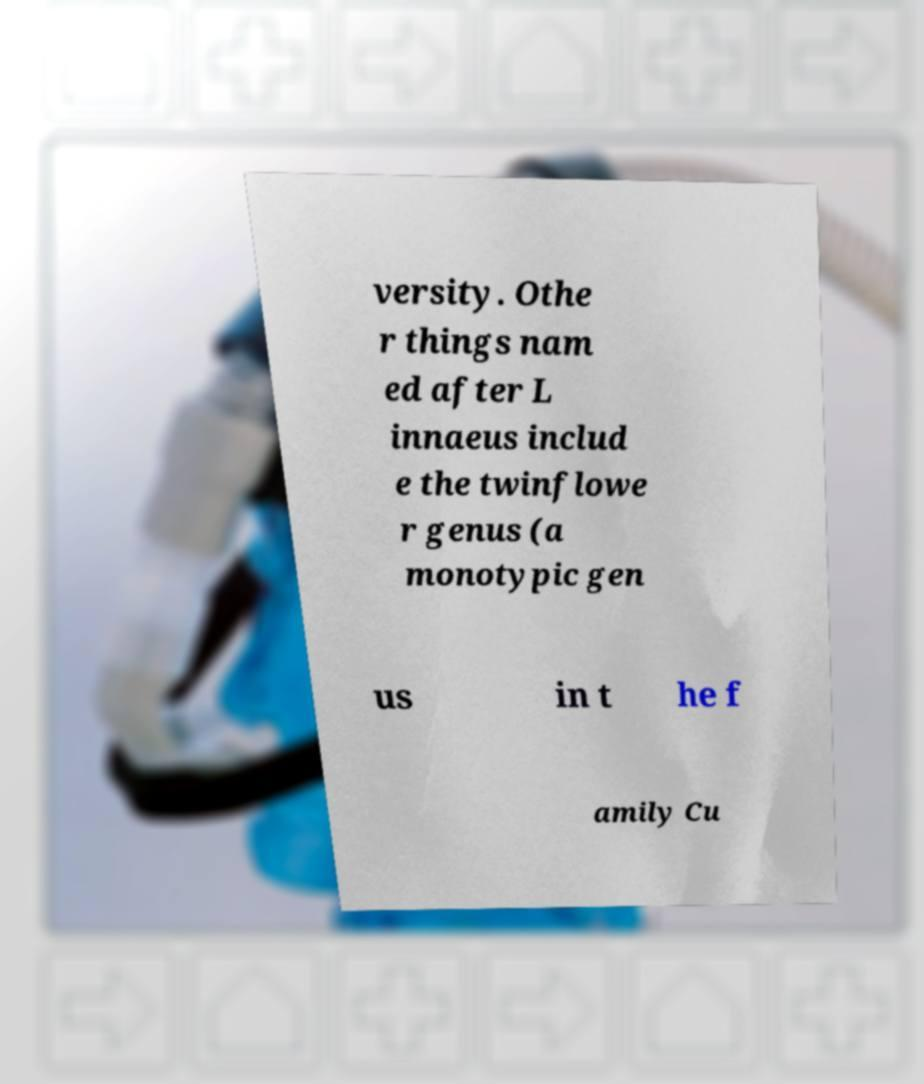Please read and relay the text visible in this image. What does it say? versity. Othe r things nam ed after L innaeus includ e the twinflowe r genus (a monotypic gen us in t he f amily Cu 